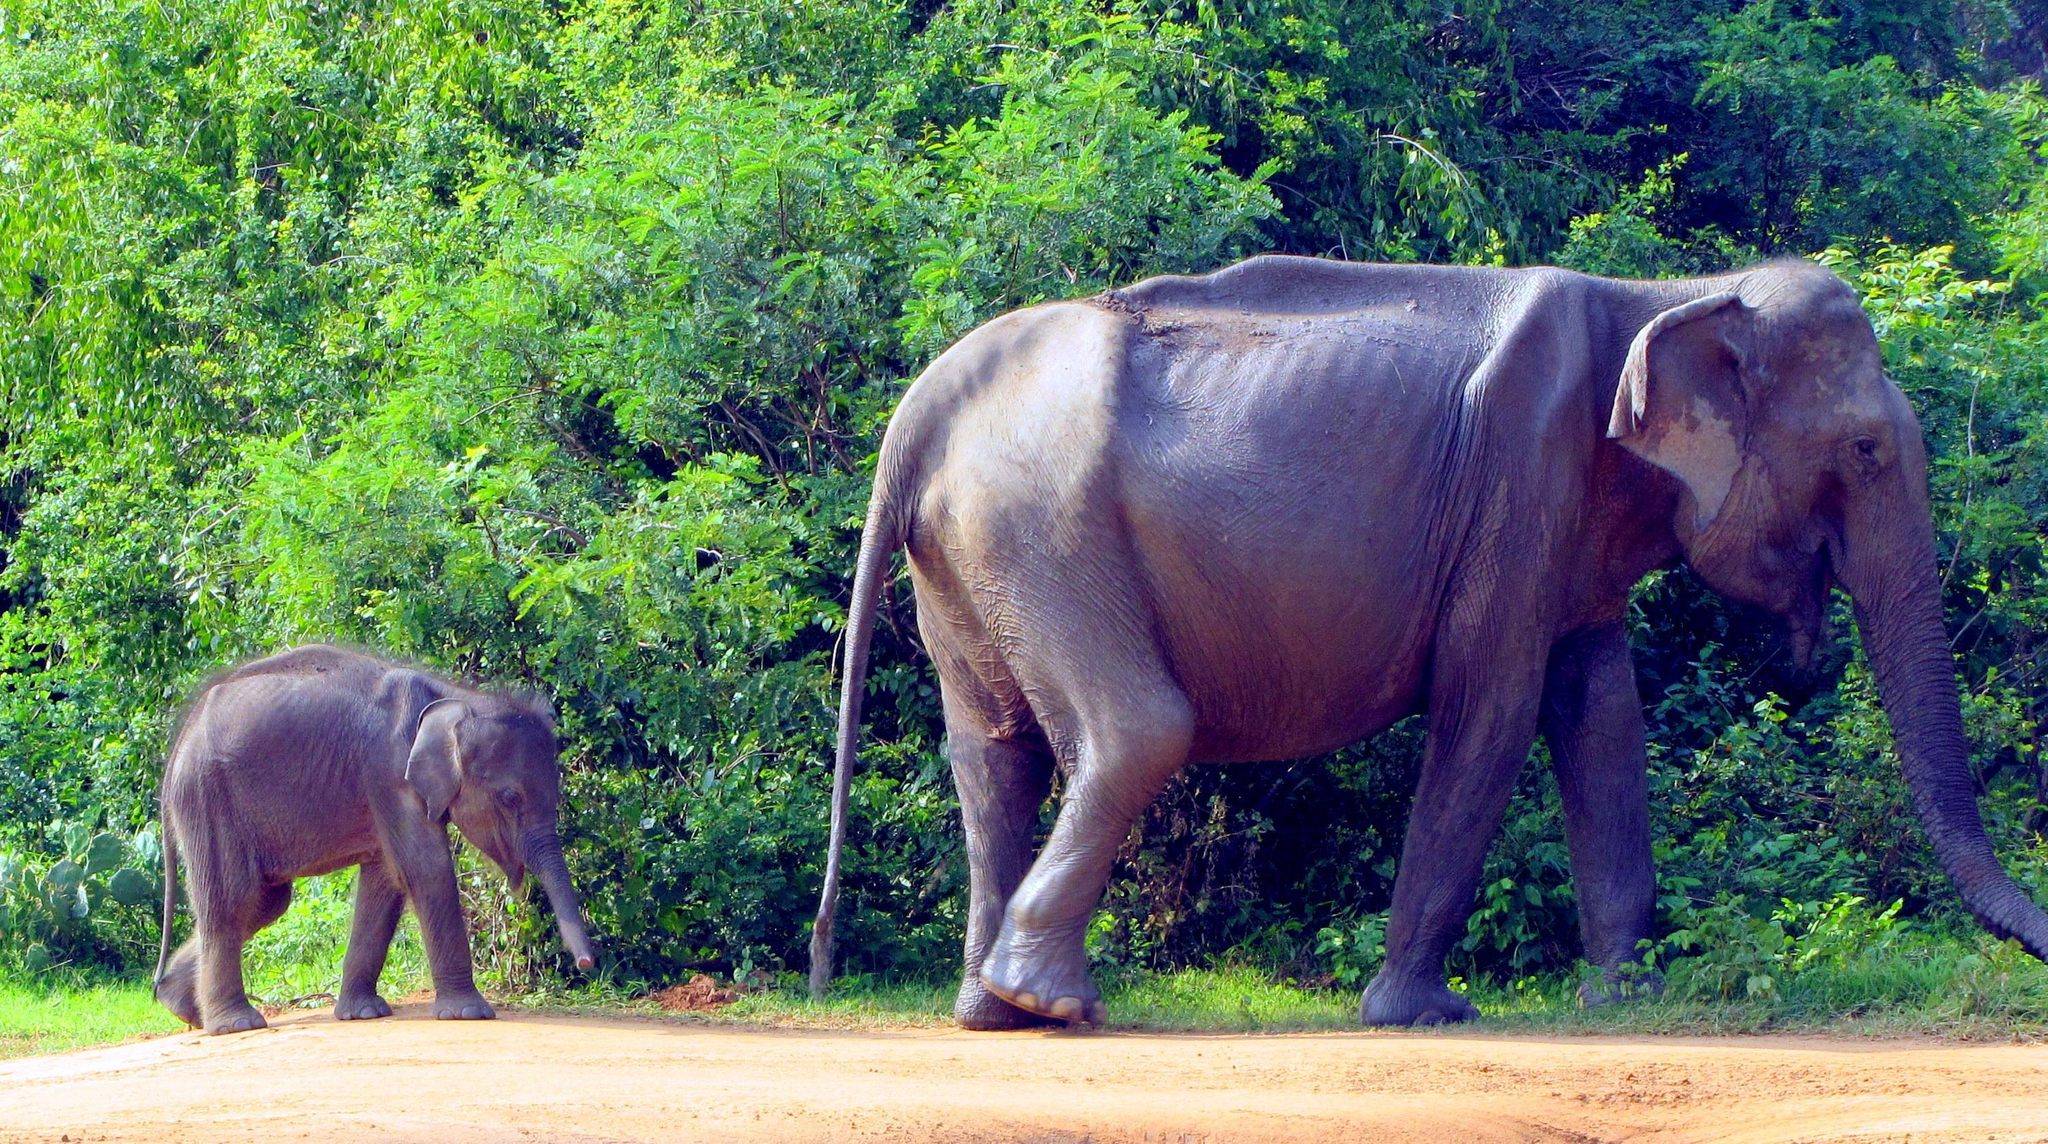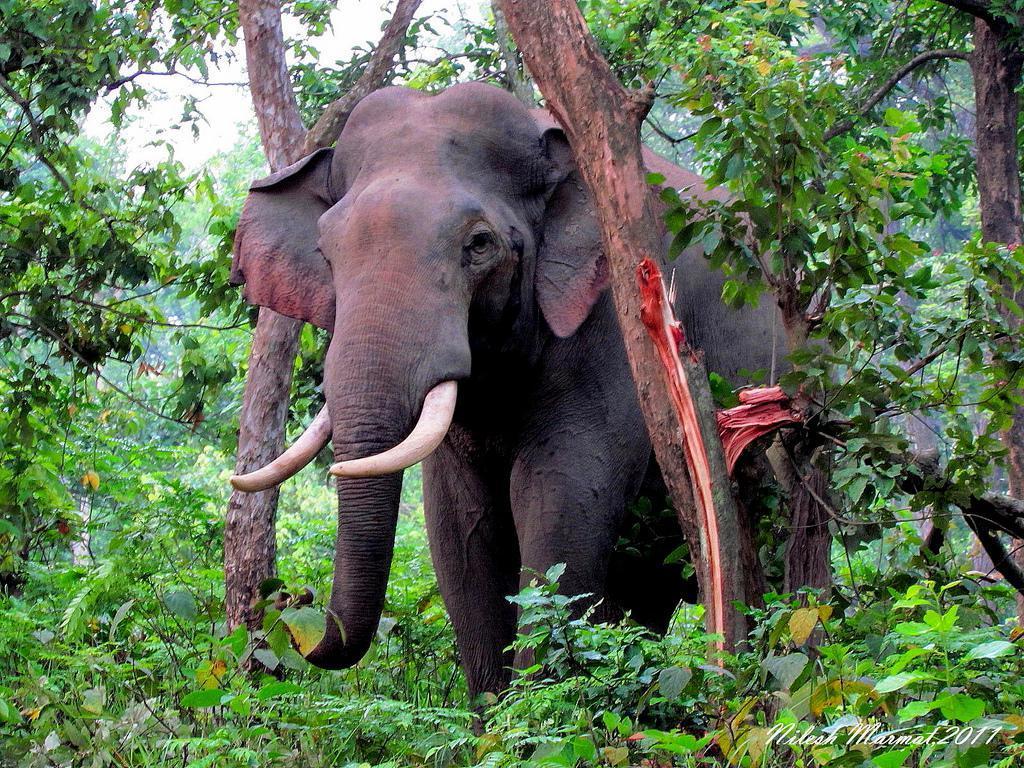The first image is the image on the left, the second image is the image on the right. For the images displayed, is the sentence "In the right image the elephant has tusks" factually correct? Answer yes or no. Yes. The first image is the image on the left, the second image is the image on the right. Assess this claim about the two images: "The left image contains a baby elephant with an adult". Correct or not? Answer yes or no. Yes. 